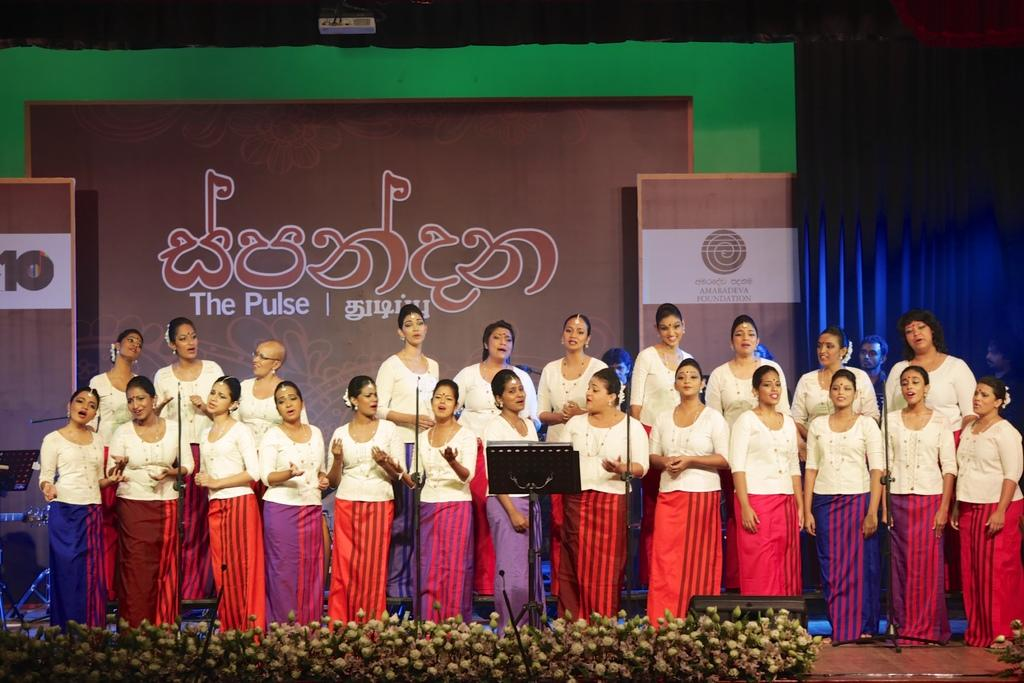What is happening in the image involving a group of women? The women are singing on a stage in the image. What can be seen behind the women on the stage? There are posters behind the women in the image. What else is present beside the posters on the stage? There are curtains beside the posters on the stage. What type of duck can be seen in the image? There is no duck present in the image. How does the anger of the women affect the performance in the image? There is no indication of anger in the image, and the women are singing, so it cannot be determined how their emotions might affect the performance. 